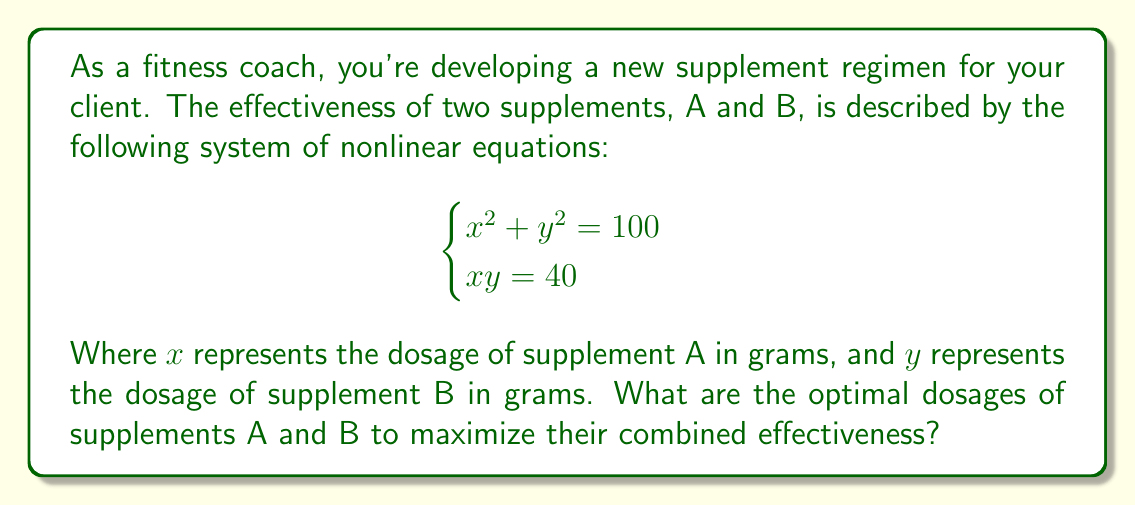What is the answer to this math problem? To solve this system of nonlinear equations, we'll use the substitution method:

1) From the second equation, we can express $y$ in terms of $x$:
   $y = \frac{40}{x}$

2) Substitute this into the first equation:
   $x^2 + (\frac{40}{x})^2 = 100$

3) Multiply both sides by $x^2$:
   $x^4 + 1600 = 100x^2$

4) Rearrange to standard form:
   $x^4 - 100x^2 + 1600 = 0$

5) This is a quadratic equation in $x^2$. Let $u = x^2$:
   $u^2 - 100u + 1600 = 0$

6) Solve using the quadratic formula:
   $u = \frac{100 \pm \sqrt{10000 - 6400}}{2} = \frac{100 \pm \sqrt{3600}}{2} = \frac{100 \pm 60}{2}$

7) This gives us two solutions:
   $u_1 = 80$ and $u_2 = 20$

8) Since $u = x^2$, we have:
   $x = \pm\sqrt{80}$ or $x = \pm\sqrt{20}$

9) Since dosage can't be negative, we take the positive values:
   $x = \sqrt{80} = 8\sqrt{2}$ or $x = \sqrt{20} = 2\sqrt{5}$

10) To find corresponding $y$ values, use $y = \frac{40}{x}$:
    For $x = 8\sqrt{2}$: $y = \frac{40}{8\sqrt{2}} = \frac{5}{\sqrt{2}} = 5\sqrt{2}$
    For $x = 2\sqrt{5}$: $y = \frac{40}{2\sqrt{5}} = 2\sqrt{5}$

Therefore, there are two possible optimal dosage combinations:
(A, B) = $(8\sqrt{2}, 5\sqrt{2})$ or $(2\sqrt{5}, 2\sqrt{5})$

Both solutions satisfy the original equations and provide the same total dosage of 100 grams.
Answer: $(8\sqrt{2}, 5\sqrt{2})$ or $(2\sqrt{5}, 2\sqrt{5})$ grams 